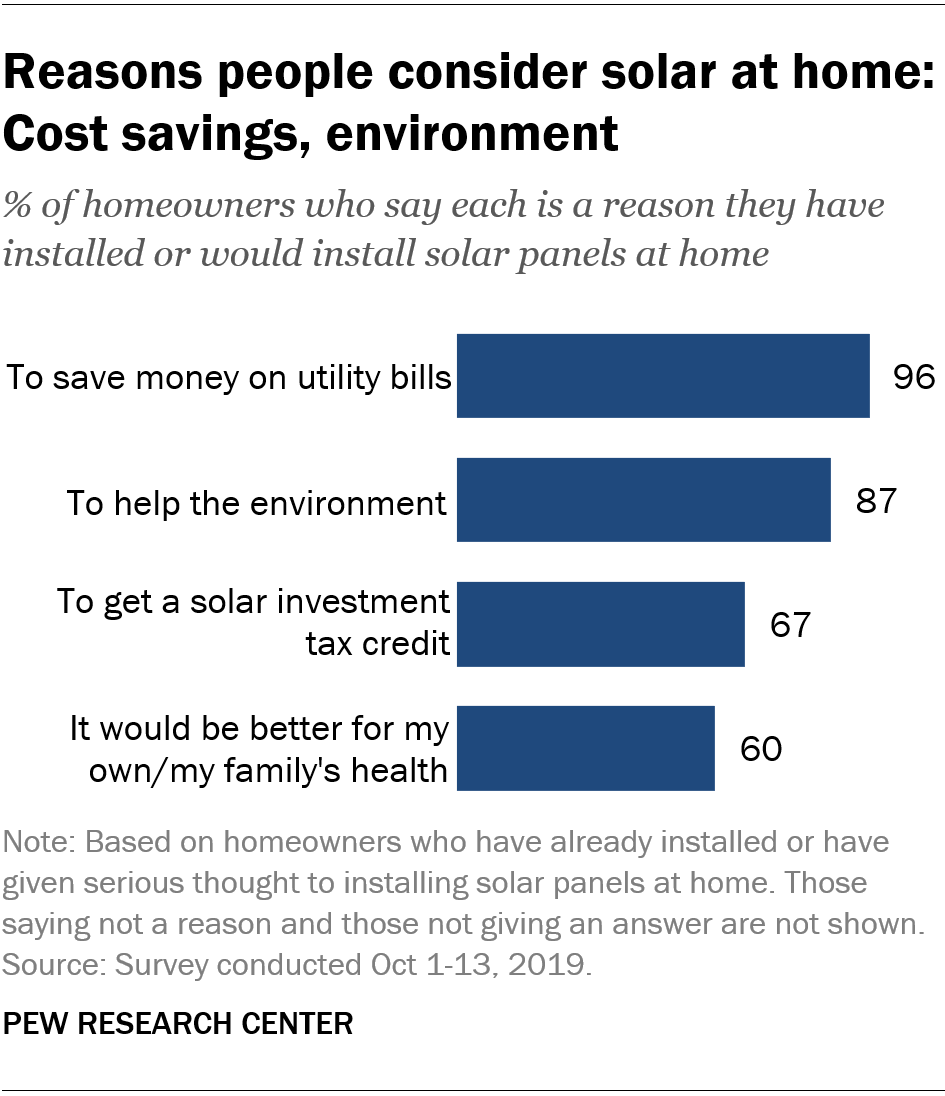Indicate a few pertinent items in this graphic. The value of bars is decreasing from top to bottom. The lowest value of bar 67 is not 